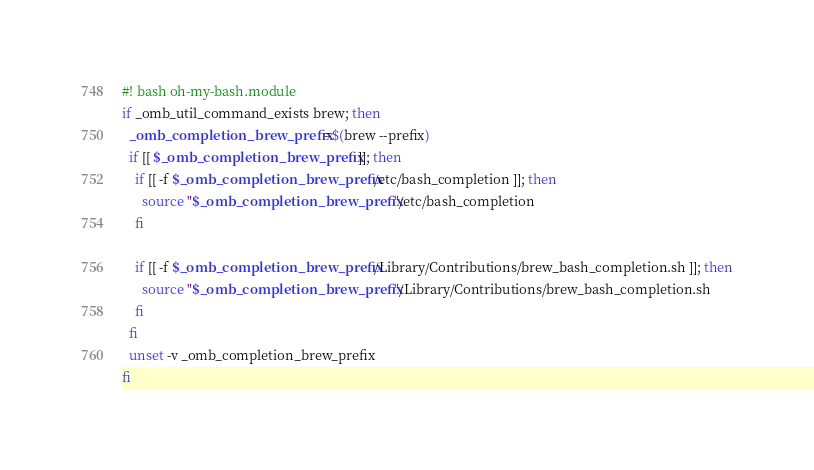<code> <loc_0><loc_0><loc_500><loc_500><_Bash_>#! bash oh-my-bash.module
if _omb_util_command_exists brew; then
  _omb_completion_brew_prefix=$(brew --prefix)
  if [[ $_omb_completion_brew_prefix ]]; then
    if [[ -f $_omb_completion_brew_prefix/etc/bash_completion ]]; then
      source "$_omb_completion_brew_prefix"/etc/bash_completion
    fi

    if [[ -f $_omb_completion_brew_prefix/Library/Contributions/brew_bash_completion.sh ]]; then
      source "$_omb_completion_brew_prefix"/Library/Contributions/brew_bash_completion.sh
    fi
  fi
  unset -v _omb_completion_brew_prefix
fi
</code> 